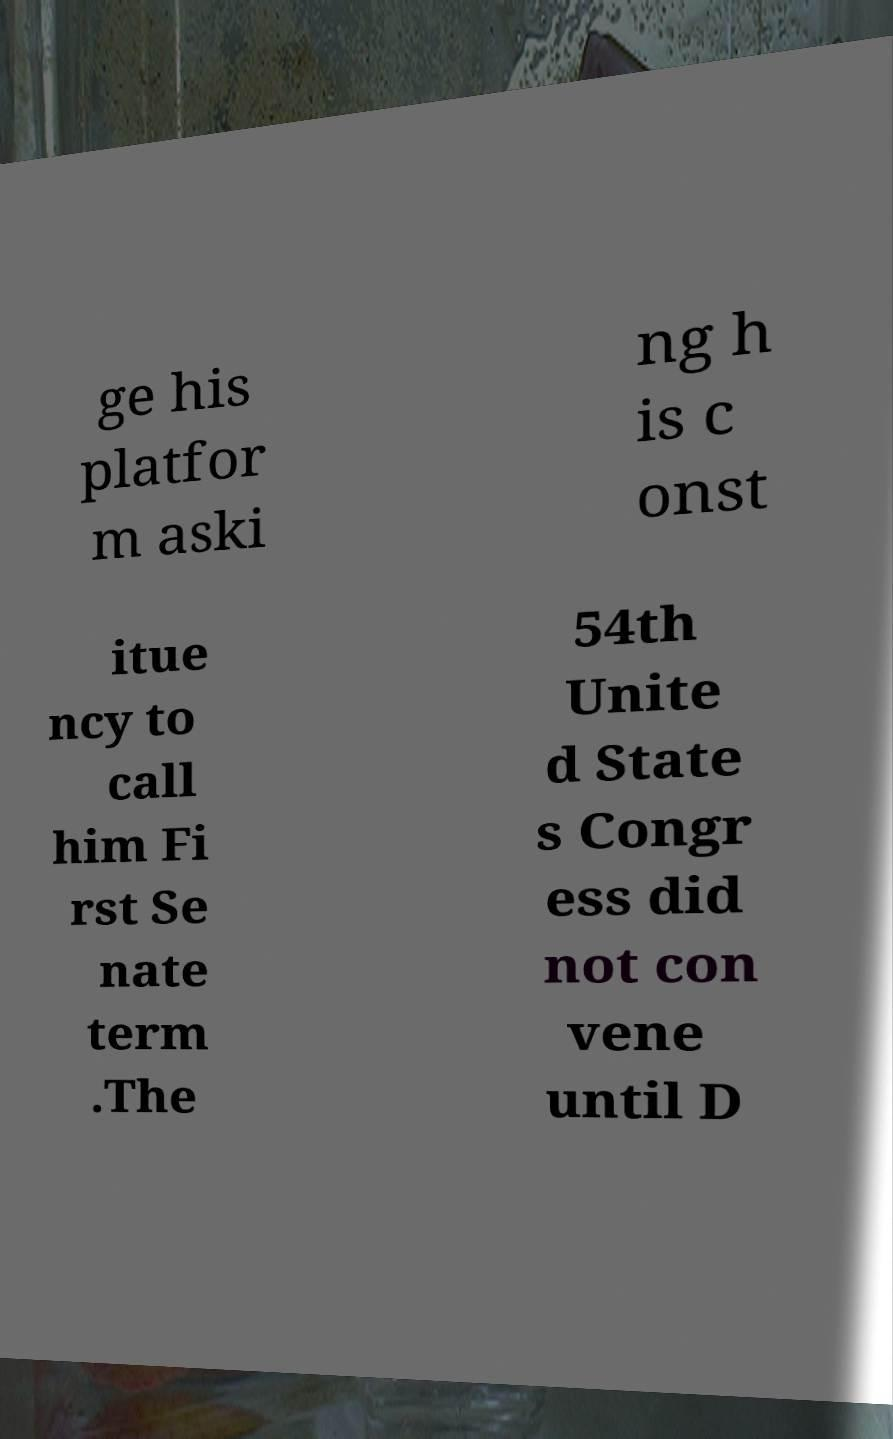What messages or text are displayed in this image? I need them in a readable, typed format. ge his platfor m aski ng h is c onst itue ncy to call him Fi rst Se nate term .The 54th Unite d State s Congr ess did not con vene until D 